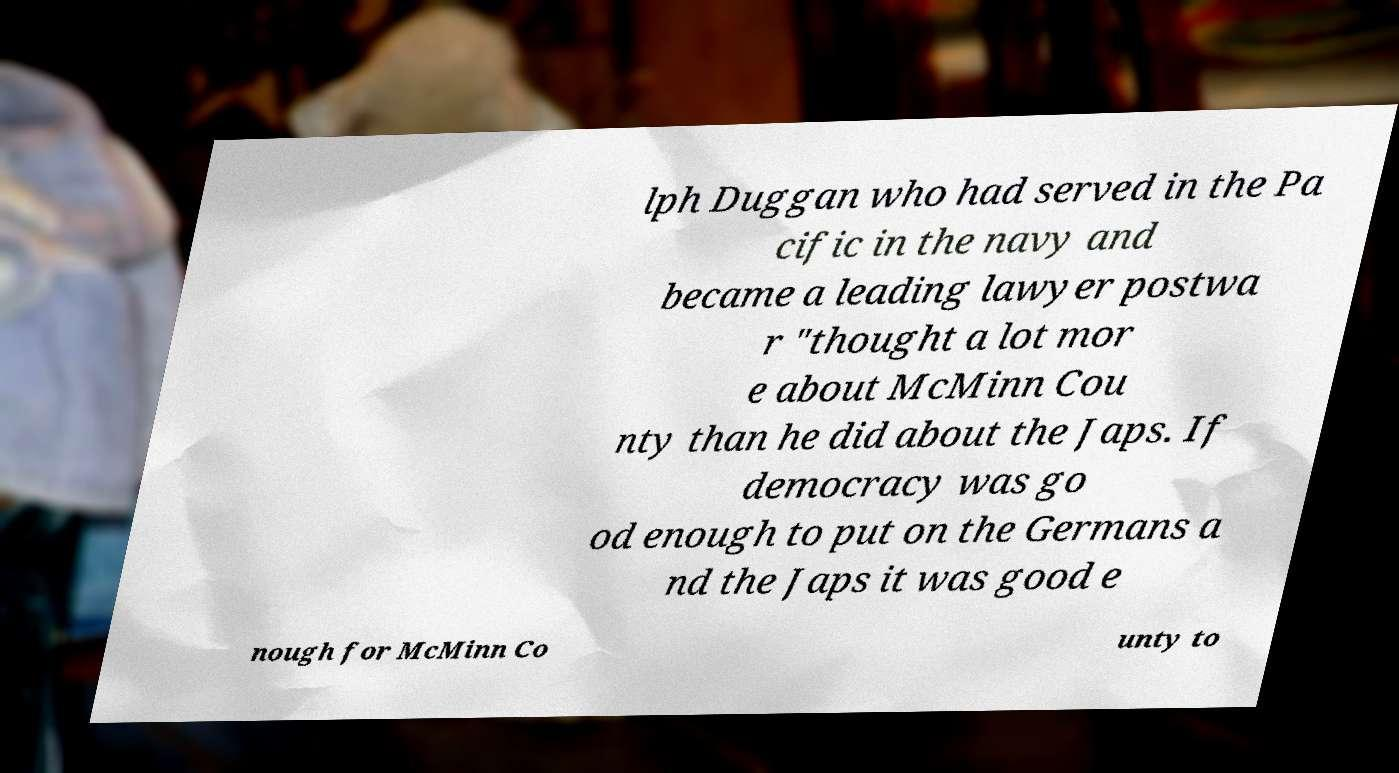Can you accurately transcribe the text from the provided image for me? lph Duggan who had served in the Pa cific in the navy and became a leading lawyer postwa r "thought a lot mor e about McMinn Cou nty than he did about the Japs. If democracy was go od enough to put on the Germans a nd the Japs it was good e nough for McMinn Co unty to 